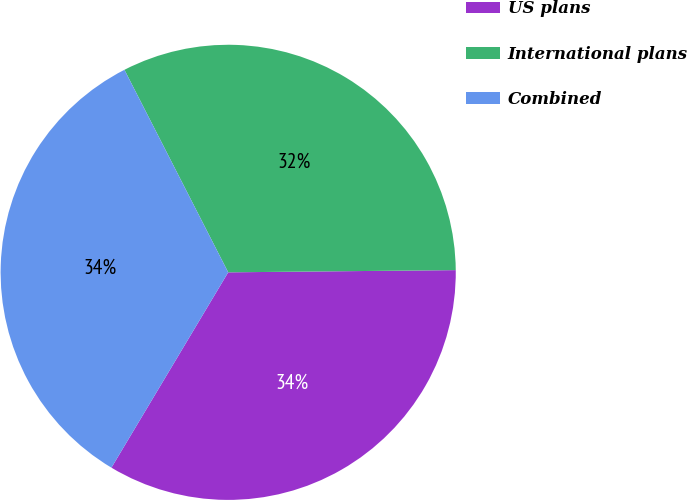<chart> <loc_0><loc_0><loc_500><loc_500><pie_chart><fcel>US plans<fcel>International plans<fcel>Combined<nl><fcel>33.73%<fcel>32.38%<fcel>33.89%<nl></chart> 